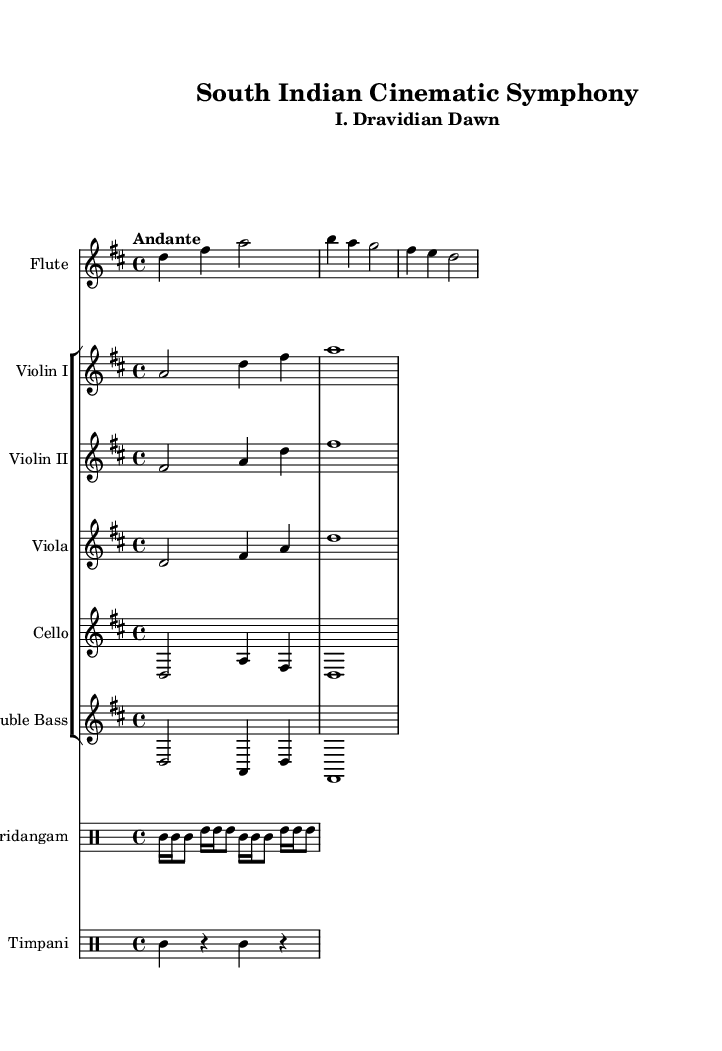What is the key signature of this music? The key signature is indicated as D major, which has two sharps: F# and C#. This can be identified by looking at the key signature at the beginning of the sheet music.
Answer: D major What is the time signature of this piece? The time signature is represented as 4/4 at the beginning of the score, indicating four beats per measure and a quarter note receives one beat. This can be found in the top left section of the score.
Answer: 4/4 What is the tempo marking for this symphony? The tempo marking is "Andante", which typically indicates a moderate tempo, generally considered to be a walking pace. This marking appears at the beginning of the score right after the time signature.
Answer: Andante How many instruments are in the string section? The string section includes five instruments: Violin I, Violin II, Viola, Cello, and Double Bass. This can be counted from the staff group in the score dedicated to string instruments.
Answer: Five Which instrument plays the rhythmic accompaniment? The instrument that provides the rhythmic accompaniment in this score is the Mridangam. This is evident from the distinct drum staff dedicated to it, which includes traditional rhythmic patterns.
Answer: Mridangam What is the last note value of the flute part? The last note value of the flute part is a half note (d2), which indicates that it lasts for two beats. This can be confirmed by examining the last note in the flute staff.
Answer: Half note 